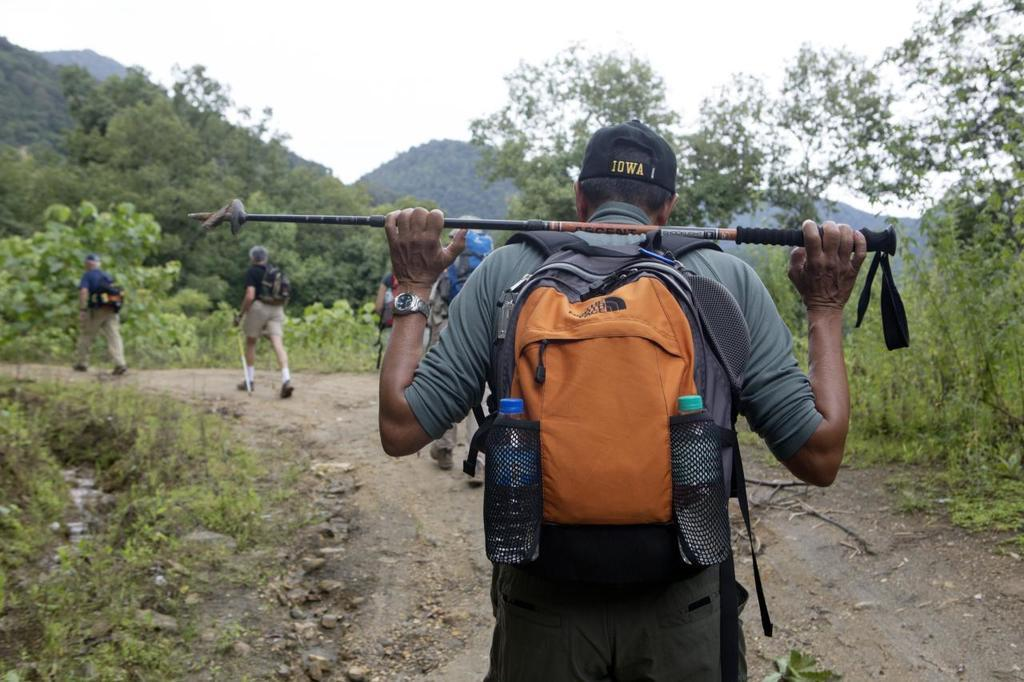<image>
Describe the image concisely. A hiker wearing an Iowa hat holds a walking stick over his shoulder. 